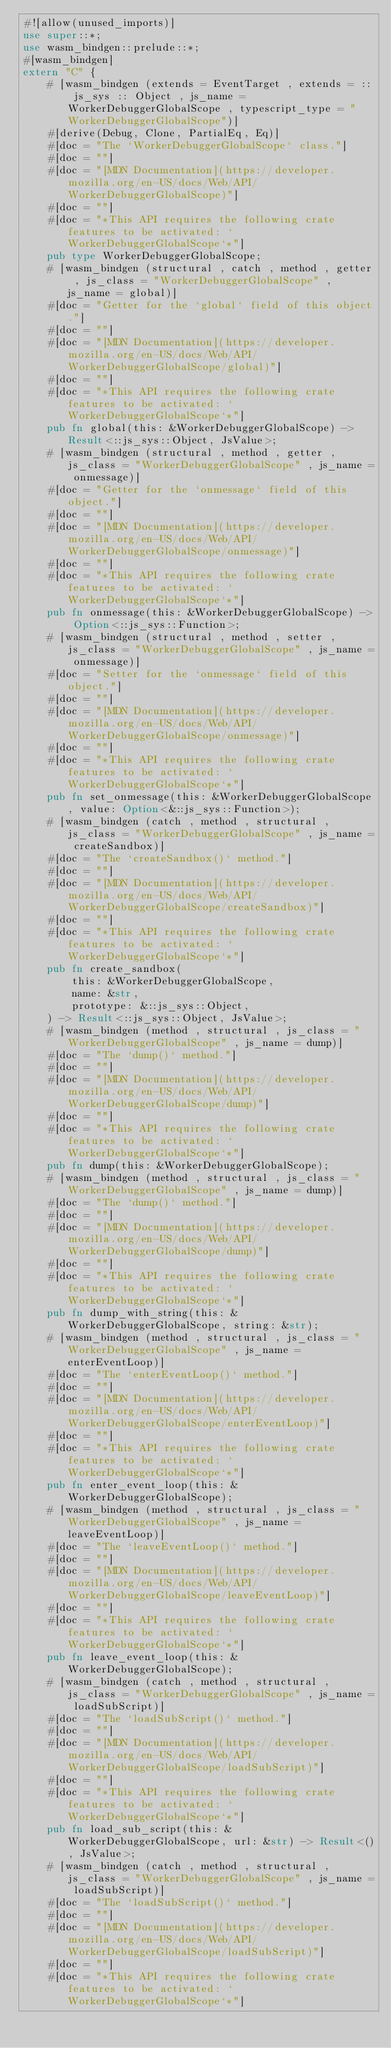Convert code to text. <code><loc_0><loc_0><loc_500><loc_500><_Rust_>#![allow(unused_imports)]
use super::*;
use wasm_bindgen::prelude::*;
#[wasm_bindgen]
extern "C" {
    # [wasm_bindgen (extends = EventTarget , extends = :: js_sys :: Object , js_name = WorkerDebuggerGlobalScope , typescript_type = "WorkerDebuggerGlobalScope")]
    #[derive(Debug, Clone, PartialEq, Eq)]
    #[doc = "The `WorkerDebuggerGlobalScope` class."]
    #[doc = ""]
    #[doc = "[MDN Documentation](https://developer.mozilla.org/en-US/docs/Web/API/WorkerDebuggerGlobalScope)"]
    #[doc = ""]
    #[doc = "*This API requires the following crate features to be activated: `WorkerDebuggerGlobalScope`*"]
    pub type WorkerDebuggerGlobalScope;
    # [wasm_bindgen (structural , catch , method , getter , js_class = "WorkerDebuggerGlobalScope" , js_name = global)]
    #[doc = "Getter for the `global` field of this object."]
    #[doc = ""]
    #[doc = "[MDN Documentation](https://developer.mozilla.org/en-US/docs/Web/API/WorkerDebuggerGlobalScope/global)"]
    #[doc = ""]
    #[doc = "*This API requires the following crate features to be activated: `WorkerDebuggerGlobalScope`*"]
    pub fn global(this: &WorkerDebuggerGlobalScope) -> Result<::js_sys::Object, JsValue>;
    # [wasm_bindgen (structural , method , getter , js_class = "WorkerDebuggerGlobalScope" , js_name = onmessage)]
    #[doc = "Getter for the `onmessage` field of this object."]
    #[doc = ""]
    #[doc = "[MDN Documentation](https://developer.mozilla.org/en-US/docs/Web/API/WorkerDebuggerGlobalScope/onmessage)"]
    #[doc = ""]
    #[doc = "*This API requires the following crate features to be activated: `WorkerDebuggerGlobalScope`*"]
    pub fn onmessage(this: &WorkerDebuggerGlobalScope) -> Option<::js_sys::Function>;
    # [wasm_bindgen (structural , method , setter , js_class = "WorkerDebuggerGlobalScope" , js_name = onmessage)]
    #[doc = "Setter for the `onmessage` field of this object."]
    #[doc = ""]
    #[doc = "[MDN Documentation](https://developer.mozilla.org/en-US/docs/Web/API/WorkerDebuggerGlobalScope/onmessage)"]
    #[doc = ""]
    #[doc = "*This API requires the following crate features to be activated: `WorkerDebuggerGlobalScope`*"]
    pub fn set_onmessage(this: &WorkerDebuggerGlobalScope, value: Option<&::js_sys::Function>);
    # [wasm_bindgen (catch , method , structural , js_class = "WorkerDebuggerGlobalScope" , js_name = createSandbox)]
    #[doc = "The `createSandbox()` method."]
    #[doc = ""]
    #[doc = "[MDN Documentation](https://developer.mozilla.org/en-US/docs/Web/API/WorkerDebuggerGlobalScope/createSandbox)"]
    #[doc = ""]
    #[doc = "*This API requires the following crate features to be activated: `WorkerDebuggerGlobalScope`*"]
    pub fn create_sandbox(
        this: &WorkerDebuggerGlobalScope,
        name: &str,
        prototype: &::js_sys::Object,
    ) -> Result<::js_sys::Object, JsValue>;
    # [wasm_bindgen (method , structural , js_class = "WorkerDebuggerGlobalScope" , js_name = dump)]
    #[doc = "The `dump()` method."]
    #[doc = ""]
    #[doc = "[MDN Documentation](https://developer.mozilla.org/en-US/docs/Web/API/WorkerDebuggerGlobalScope/dump)"]
    #[doc = ""]
    #[doc = "*This API requires the following crate features to be activated: `WorkerDebuggerGlobalScope`*"]
    pub fn dump(this: &WorkerDebuggerGlobalScope);
    # [wasm_bindgen (method , structural , js_class = "WorkerDebuggerGlobalScope" , js_name = dump)]
    #[doc = "The `dump()` method."]
    #[doc = ""]
    #[doc = "[MDN Documentation](https://developer.mozilla.org/en-US/docs/Web/API/WorkerDebuggerGlobalScope/dump)"]
    #[doc = ""]
    #[doc = "*This API requires the following crate features to be activated: `WorkerDebuggerGlobalScope`*"]
    pub fn dump_with_string(this: &WorkerDebuggerGlobalScope, string: &str);
    # [wasm_bindgen (method , structural , js_class = "WorkerDebuggerGlobalScope" , js_name = enterEventLoop)]
    #[doc = "The `enterEventLoop()` method."]
    #[doc = ""]
    #[doc = "[MDN Documentation](https://developer.mozilla.org/en-US/docs/Web/API/WorkerDebuggerGlobalScope/enterEventLoop)"]
    #[doc = ""]
    #[doc = "*This API requires the following crate features to be activated: `WorkerDebuggerGlobalScope`*"]
    pub fn enter_event_loop(this: &WorkerDebuggerGlobalScope);
    # [wasm_bindgen (method , structural , js_class = "WorkerDebuggerGlobalScope" , js_name = leaveEventLoop)]
    #[doc = "The `leaveEventLoop()` method."]
    #[doc = ""]
    #[doc = "[MDN Documentation](https://developer.mozilla.org/en-US/docs/Web/API/WorkerDebuggerGlobalScope/leaveEventLoop)"]
    #[doc = ""]
    #[doc = "*This API requires the following crate features to be activated: `WorkerDebuggerGlobalScope`*"]
    pub fn leave_event_loop(this: &WorkerDebuggerGlobalScope);
    # [wasm_bindgen (catch , method , structural , js_class = "WorkerDebuggerGlobalScope" , js_name = loadSubScript)]
    #[doc = "The `loadSubScript()` method."]
    #[doc = ""]
    #[doc = "[MDN Documentation](https://developer.mozilla.org/en-US/docs/Web/API/WorkerDebuggerGlobalScope/loadSubScript)"]
    #[doc = ""]
    #[doc = "*This API requires the following crate features to be activated: `WorkerDebuggerGlobalScope`*"]
    pub fn load_sub_script(this: &WorkerDebuggerGlobalScope, url: &str) -> Result<(), JsValue>;
    # [wasm_bindgen (catch , method , structural , js_class = "WorkerDebuggerGlobalScope" , js_name = loadSubScript)]
    #[doc = "The `loadSubScript()` method."]
    #[doc = ""]
    #[doc = "[MDN Documentation](https://developer.mozilla.org/en-US/docs/Web/API/WorkerDebuggerGlobalScope/loadSubScript)"]
    #[doc = ""]
    #[doc = "*This API requires the following crate features to be activated: `WorkerDebuggerGlobalScope`*"]</code> 